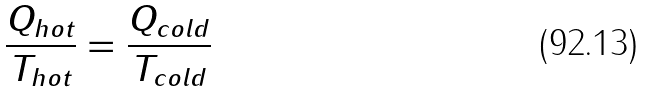<formula> <loc_0><loc_0><loc_500><loc_500>\frac { Q _ { h o t } } { T _ { h o t } } = \frac { Q _ { c o l d } } { T _ { c o l d } }</formula> 